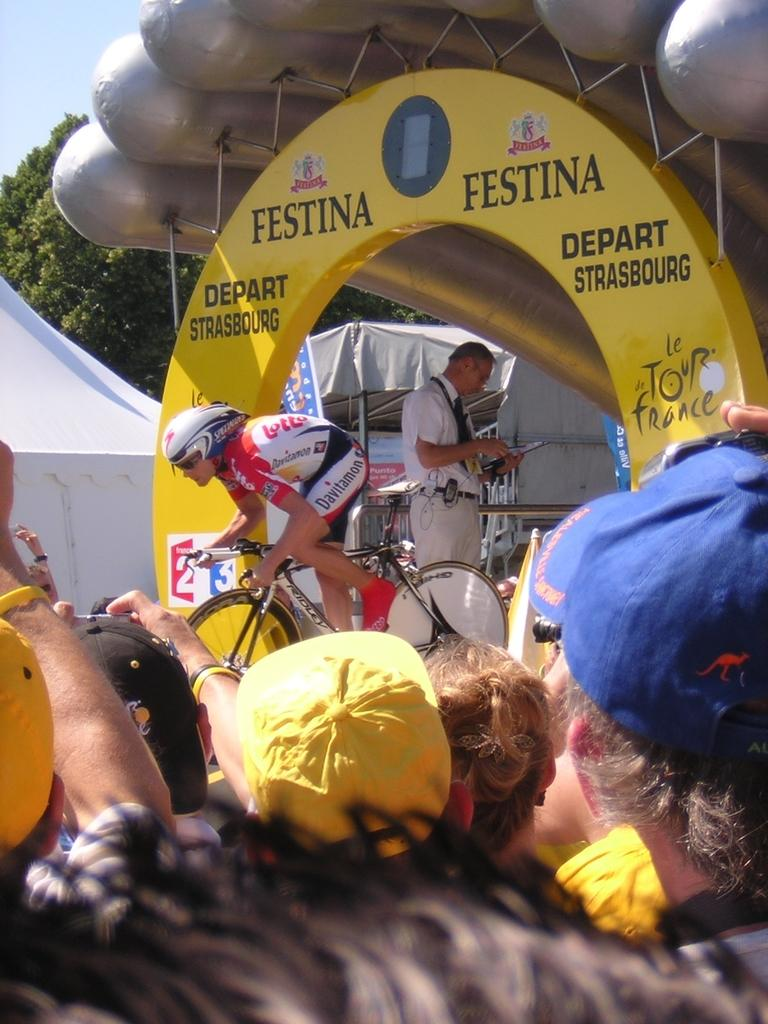What is the main subject of the image? There is a person riding a bicycle in the image. Are there any other people present in the image? Yes, there are people in the audience beside the cyclist. What can be seen in the background of the image? There are other objects in the background of the image. What type of government is depicted in the image? There is no government depicted in the image; it features a person riding a bicycle and an audience. How many hands are visible in the image? The number of hands cannot be determined from the image, as it only shows a person riding a bicycle and an audience. 